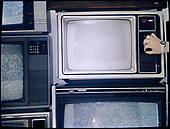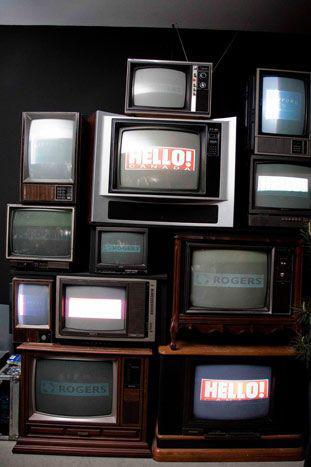The first image is the image on the left, the second image is the image on the right. Given the left and right images, does the statement "There are no more than 5 televisions in the right image." hold true? Answer yes or no. No. 